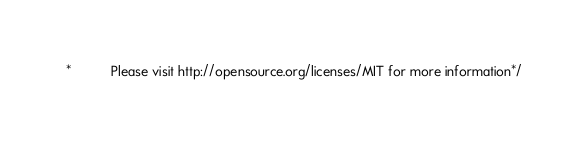Convert code to text. <code><loc_0><loc_0><loc_500><loc_500><_CSS_> *           Please visit http://opensource.org/licenses/MIT for more information*/</code> 